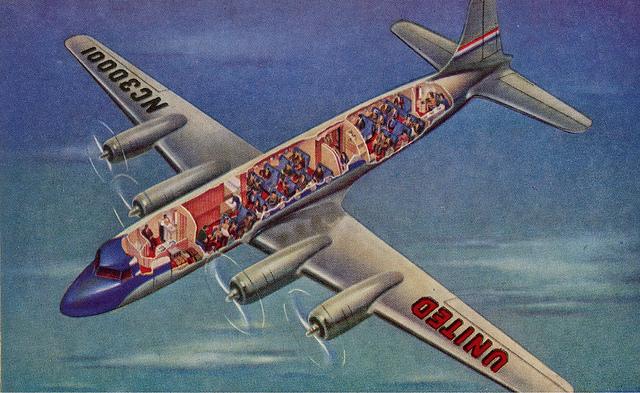Is the airplane ascending or descending?
Keep it brief. Descending. What is inside the plane?
Write a very short answer. People. Is this a real plane?
Be succinct. No. 